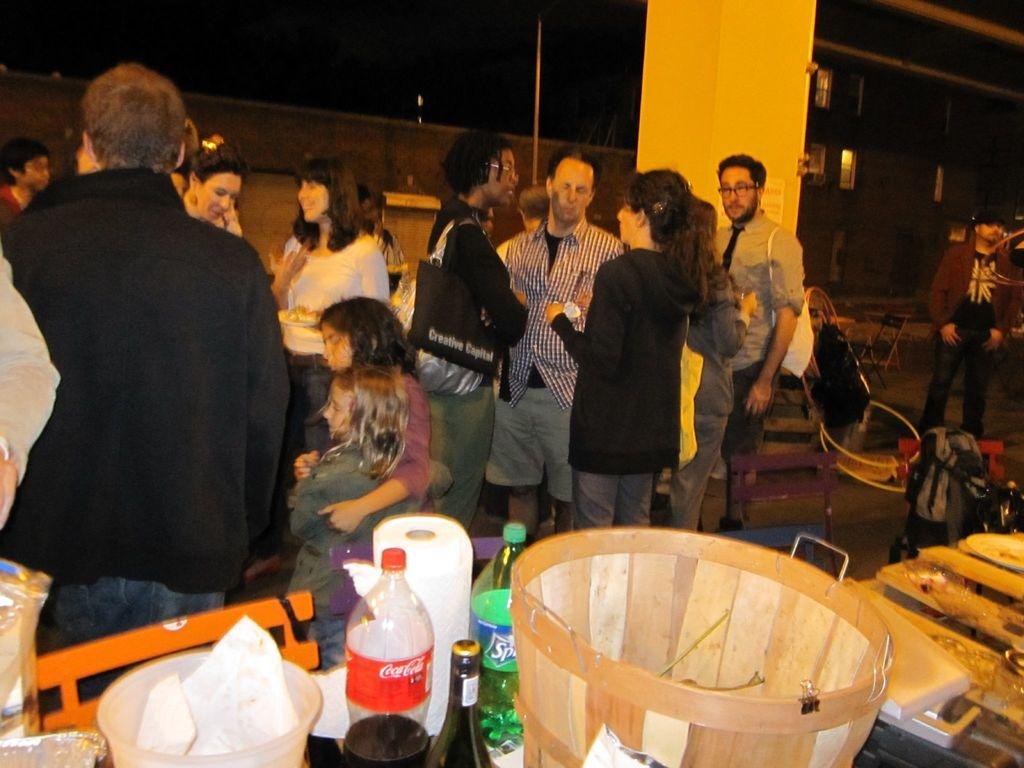What can be seen in the image in terms of people? There are people standing in the image. What type of furniture is present in the image? There are chairs and tables in the image. What objects can be found on the tables? There is a basket, bottles, and a bowl on the tables. How much profit does the baby make in the image? There is no baby present in the image, so the concept of profit does not apply. 